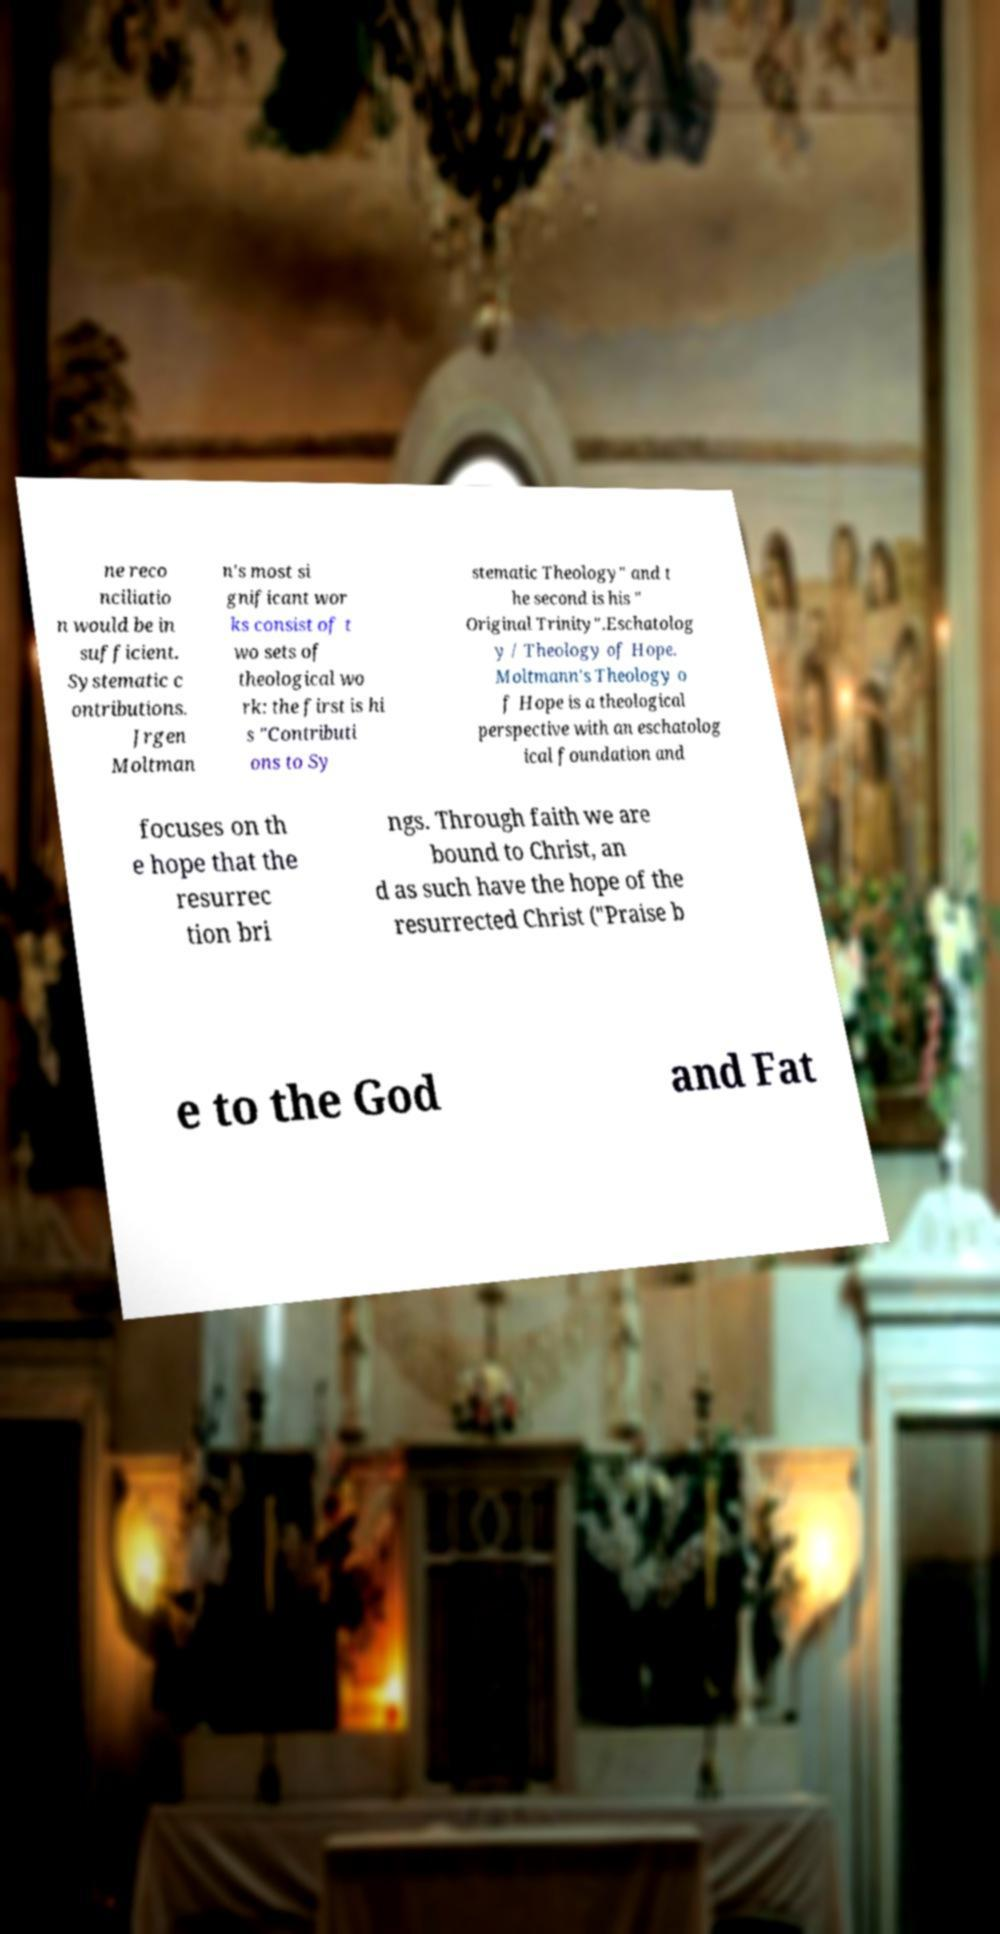Could you assist in decoding the text presented in this image and type it out clearly? ne reco nciliatio n would be in sufficient. Systematic c ontributions. Jrgen Moltman n's most si gnificant wor ks consist of t wo sets of theological wo rk: the first is hi s "Contributi ons to Sy stematic Theology" and t he second is his " Original Trinity".Eschatolog y / Theology of Hope. Moltmann's Theology o f Hope is a theological perspective with an eschatolog ical foundation and focuses on th e hope that the resurrec tion bri ngs. Through faith we are bound to Christ, an d as such have the hope of the resurrected Christ ("Praise b e to the God and Fat 